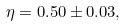<formula> <loc_0><loc_0><loc_500><loc_500>\eta = 0 . 5 0 \pm 0 . 0 3 ,</formula> 